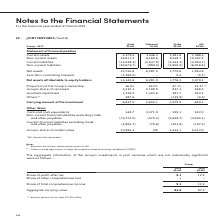According to Singapore Telecommunications's financial document, What is the topic of note 22? According to the financial document, Joint Ventures. The relevant text states: "22. JOINT VENTURES (Cont’d)..." Also, What does the line item "Others" in the table encompass? adjustments to align the respective local accounting standards to SFRS(I). The document states: "(2) Others include adjustments to align the respective local accounting standards to SFRS(I)...." Also, Does the 23.3% of the group's ownership in AIS include any indirect equity interest? According to the financial document, No. The relevant text states: "ion Current assets 4,378.4 3,546.3 1,481.6 1,368.4 Non-current assets 45,611.2 6,169.6 5,548.1 10,027.2 Current liabilities (13,568.3) (2,547.9) (2,344.3..." Additionally, Which is the largest joint venture of Singtel, in terms of the proportion of Group's ownership? According to the financial document, Globe. The relevant text states: "Group - 2017 Airtel S$ Mil Telkomsel S$ Mil Globe S$ Mil AIS S$ Mil..." Additionally, Which is the largest joint venture of Singtel, in terms of the carrying amount of investment? According to the financial document, Airtel. The relevant text states: "Group - 2017 Airtel S$ Mil Telkomsel S$ Mil Globe S$ Mil AIS S$ Mil..." Also, can you calculate: For the joint venture with Airtel, what is the financial impact of the non-controlling interests on the group's share of net assets? Based on the calculation: 1,399.0 * 36.5%, the result is 510.63 (in millions). This is based on the information: "1,775.9 1,584.9 Less : Non-controlling interests (1,399.0) - 0.4 (5.7) Proportion of the Group’s ownership 36.5% 35.0% 47.1% 23.3% (1)..." The key data points involved are: 1,399.0, 36.5. 